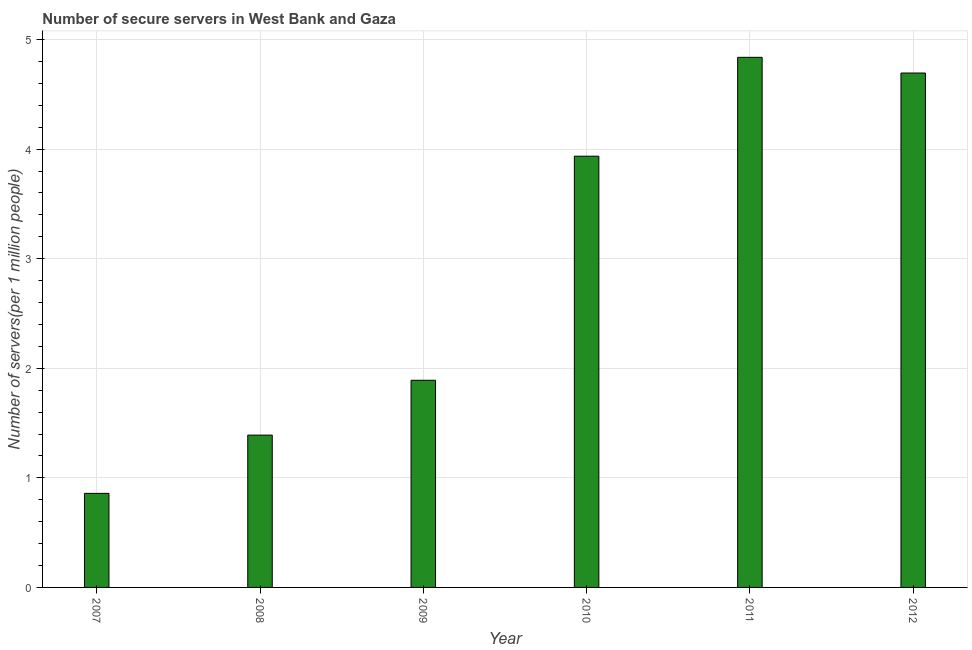What is the title of the graph?
Your answer should be compact. Number of secure servers in West Bank and Gaza. What is the label or title of the X-axis?
Your response must be concise. Year. What is the label or title of the Y-axis?
Keep it short and to the point. Number of servers(per 1 million people). What is the number of secure internet servers in 2011?
Keep it short and to the point. 4.84. Across all years, what is the maximum number of secure internet servers?
Offer a terse response. 4.84. Across all years, what is the minimum number of secure internet servers?
Provide a succinct answer. 0.86. What is the sum of the number of secure internet servers?
Offer a terse response. 17.61. What is the difference between the number of secure internet servers in 2009 and 2012?
Ensure brevity in your answer.  -2.8. What is the average number of secure internet servers per year?
Offer a very short reply. 2.94. What is the median number of secure internet servers?
Your response must be concise. 2.91. Do a majority of the years between 2008 and 2010 (inclusive) have number of secure internet servers greater than 2 ?
Provide a short and direct response. No. What is the ratio of the number of secure internet servers in 2010 to that in 2011?
Make the answer very short. 0.81. Is the difference between the number of secure internet servers in 2007 and 2009 greater than the difference between any two years?
Your response must be concise. No. What is the difference between the highest and the second highest number of secure internet servers?
Provide a succinct answer. 0.14. What is the difference between the highest and the lowest number of secure internet servers?
Your answer should be very brief. 3.98. How many bars are there?
Give a very brief answer. 6. How many years are there in the graph?
Your response must be concise. 6. What is the difference between two consecutive major ticks on the Y-axis?
Your response must be concise. 1. What is the Number of servers(per 1 million people) in 2007?
Your response must be concise. 0.86. What is the Number of servers(per 1 million people) of 2008?
Offer a very short reply. 1.39. What is the Number of servers(per 1 million people) of 2009?
Make the answer very short. 1.89. What is the Number of servers(per 1 million people) in 2010?
Provide a short and direct response. 3.94. What is the Number of servers(per 1 million people) in 2011?
Your response must be concise. 4.84. What is the Number of servers(per 1 million people) in 2012?
Give a very brief answer. 4.69. What is the difference between the Number of servers(per 1 million people) in 2007 and 2008?
Give a very brief answer. -0.53. What is the difference between the Number of servers(per 1 million people) in 2007 and 2009?
Your answer should be very brief. -1.03. What is the difference between the Number of servers(per 1 million people) in 2007 and 2010?
Keep it short and to the point. -3.08. What is the difference between the Number of servers(per 1 million people) in 2007 and 2011?
Offer a very short reply. -3.98. What is the difference between the Number of servers(per 1 million people) in 2007 and 2012?
Provide a succinct answer. -3.84. What is the difference between the Number of servers(per 1 million people) in 2008 and 2009?
Provide a short and direct response. -0.5. What is the difference between the Number of servers(per 1 million people) in 2008 and 2010?
Offer a very short reply. -2.55. What is the difference between the Number of servers(per 1 million people) in 2008 and 2011?
Offer a terse response. -3.45. What is the difference between the Number of servers(per 1 million people) in 2008 and 2012?
Provide a succinct answer. -3.3. What is the difference between the Number of servers(per 1 million people) in 2009 and 2010?
Offer a very short reply. -2.05. What is the difference between the Number of servers(per 1 million people) in 2009 and 2011?
Ensure brevity in your answer.  -2.95. What is the difference between the Number of servers(per 1 million people) in 2009 and 2012?
Your answer should be very brief. -2.8. What is the difference between the Number of servers(per 1 million people) in 2010 and 2011?
Your response must be concise. -0.9. What is the difference between the Number of servers(per 1 million people) in 2010 and 2012?
Offer a terse response. -0.76. What is the difference between the Number of servers(per 1 million people) in 2011 and 2012?
Provide a short and direct response. 0.14. What is the ratio of the Number of servers(per 1 million people) in 2007 to that in 2008?
Your response must be concise. 0.62. What is the ratio of the Number of servers(per 1 million people) in 2007 to that in 2009?
Give a very brief answer. 0.45. What is the ratio of the Number of servers(per 1 million people) in 2007 to that in 2010?
Your response must be concise. 0.22. What is the ratio of the Number of servers(per 1 million people) in 2007 to that in 2011?
Your answer should be very brief. 0.18. What is the ratio of the Number of servers(per 1 million people) in 2007 to that in 2012?
Your answer should be very brief. 0.18. What is the ratio of the Number of servers(per 1 million people) in 2008 to that in 2009?
Your answer should be compact. 0.73. What is the ratio of the Number of servers(per 1 million people) in 2008 to that in 2010?
Your answer should be compact. 0.35. What is the ratio of the Number of servers(per 1 million people) in 2008 to that in 2011?
Your response must be concise. 0.29. What is the ratio of the Number of servers(per 1 million people) in 2008 to that in 2012?
Provide a succinct answer. 0.3. What is the ratio of the Number of servers(per 1 million people) in 2009 to that in 2010?
Your response must be concise. 0.48. What is the ratio of the Number of servers(per 1 million people) in 2009 to that in 2011?
Provide a short and direct response. 0.39. What is the ratio of the Number of servers(per 1 million people) in 2009 to that in 2012?
Provide a succinct answer. 0.4. What is the ratio of the Number of servers(per 1 million people) in 2010 to that in 2011?
Your response must be concise. 0.81. What is the ratio of the Number of servers(per 1 million people) in 2010 to that in 2012?
Your response must be concise. 0.84. What is the ratio of the Number of servers(per 1 million people) in 2011 to that in 2012?
Offer a very short reply. 1.03. 